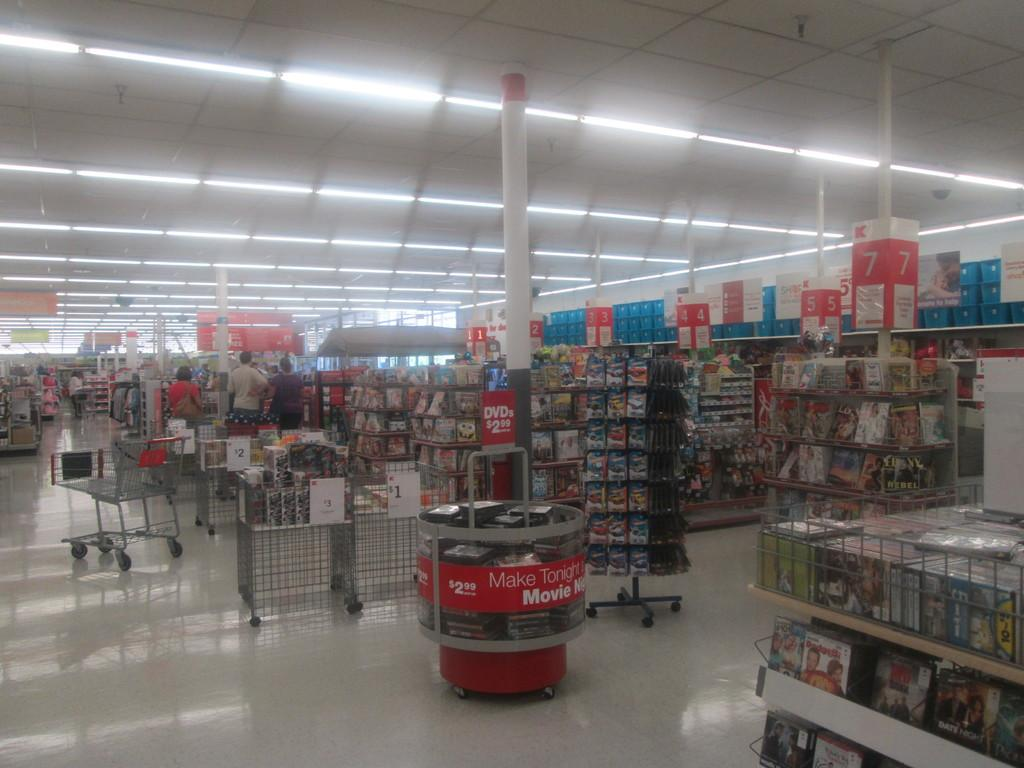Provide a one-sentence caption for the provided image. DVDs are sold for 2.99 in the display case. 